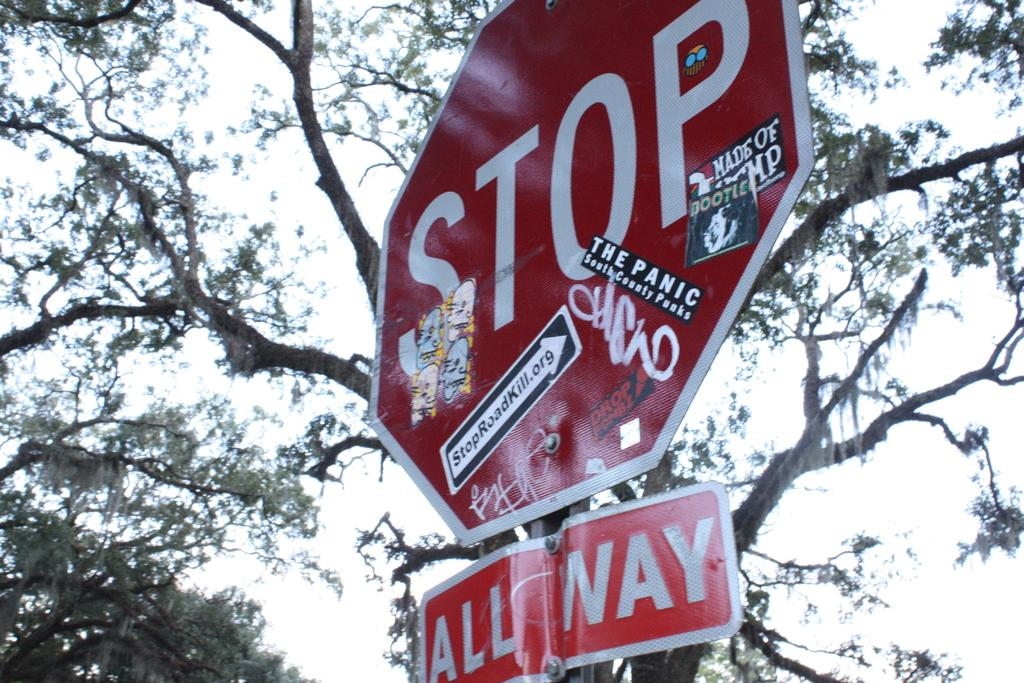<image>
Share a concise interpretation of the image provided. An all-way stop sign has many stickers on it, including one that says 'stoproadkill.org[. 